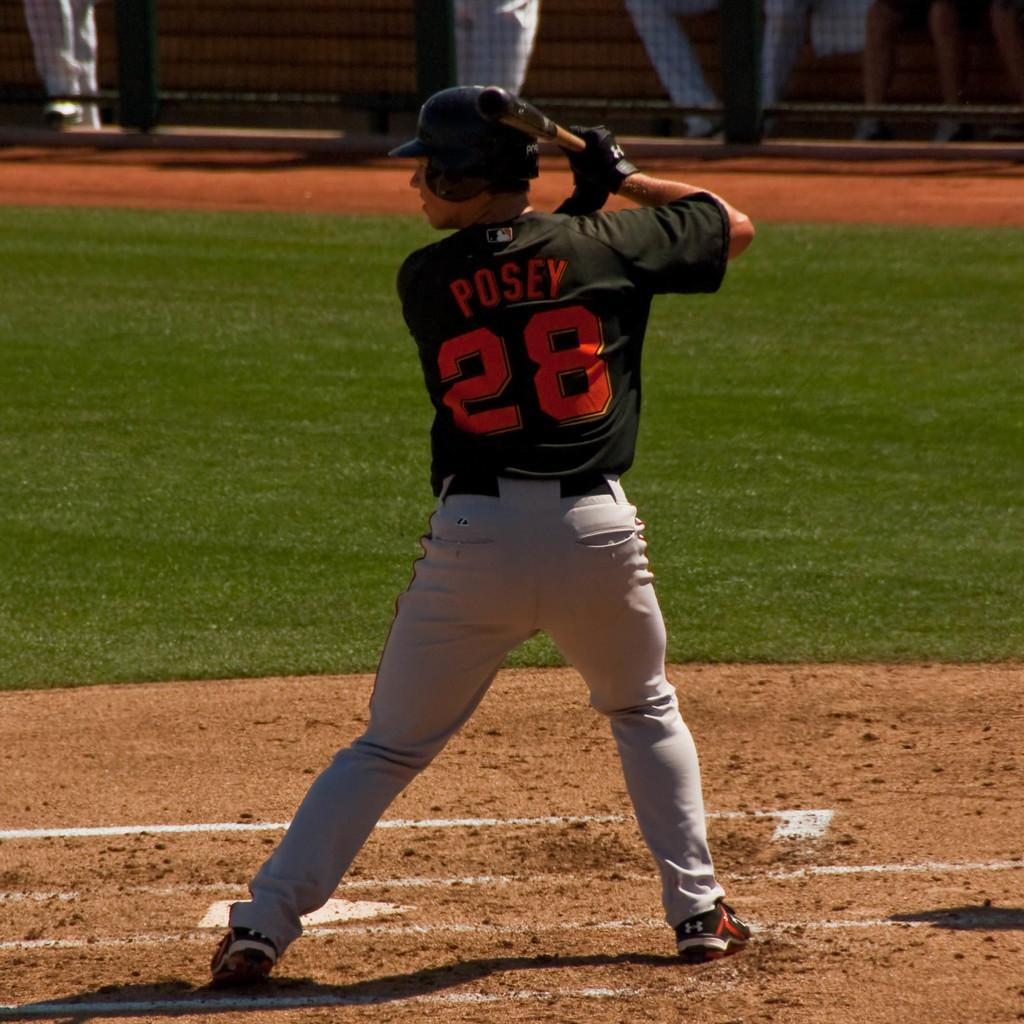<image>
Provide a brief description of the given image. A baseball player has the number 28 on his shirt. 